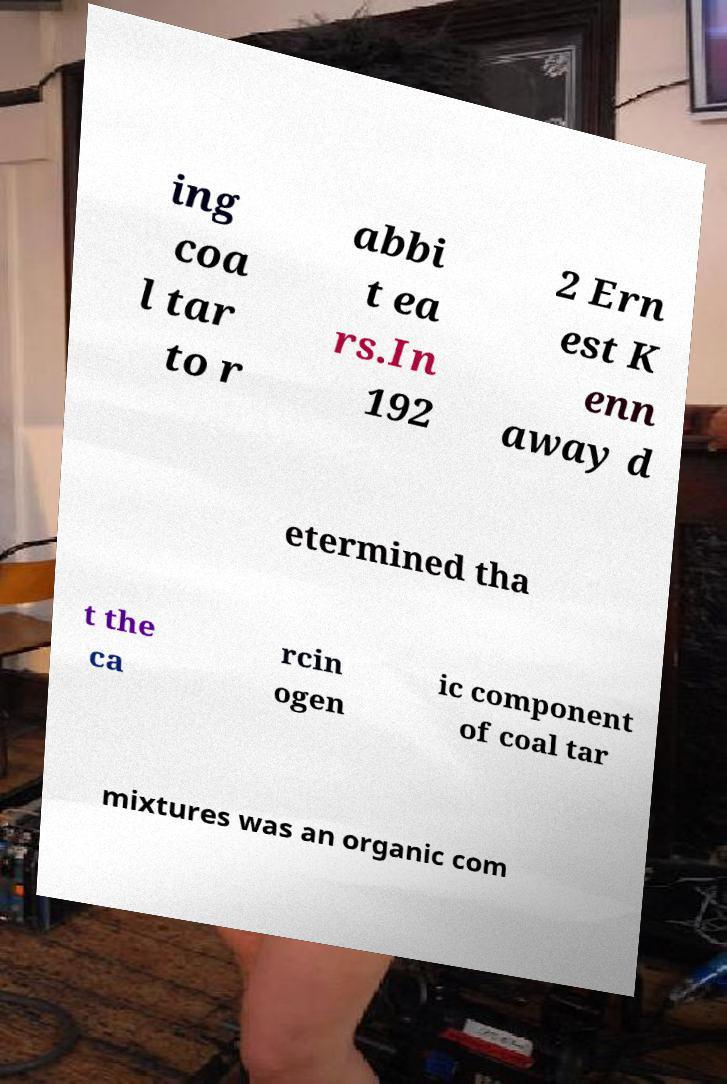There's text embedded in this image that I need extracted. Can you transcribe it verbatim? ing coa l tar to r abbi t ea rs.In 192 2 Ern est K enn away d etermined tha t the ca rcin ogen ic component of coal tar mixtures was an organic com 